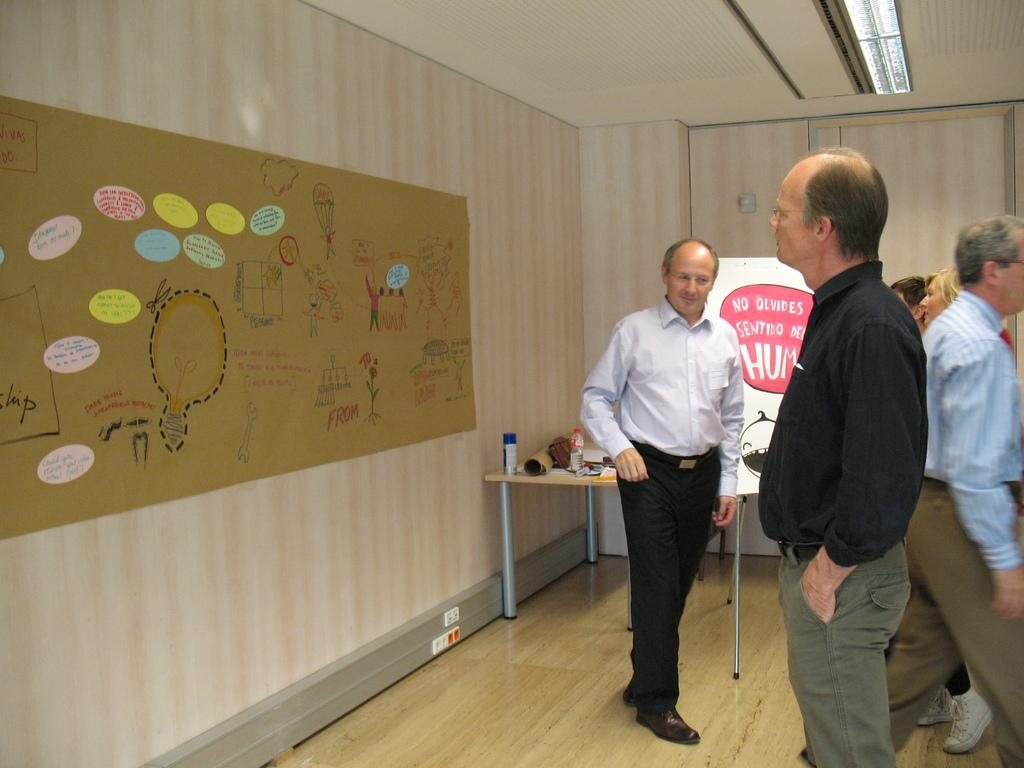What can be seen in the image involving people? There are people standing in the image. What is on the wall in the image? There is a poster on the wall in the image. What type of furniture is present in the image? There is a table in the image. How many chickens are sitting on the table in the image? There are no chickens present in the image. What type of material is the table made of in the image? The provided facts do not mention the material of the table. 